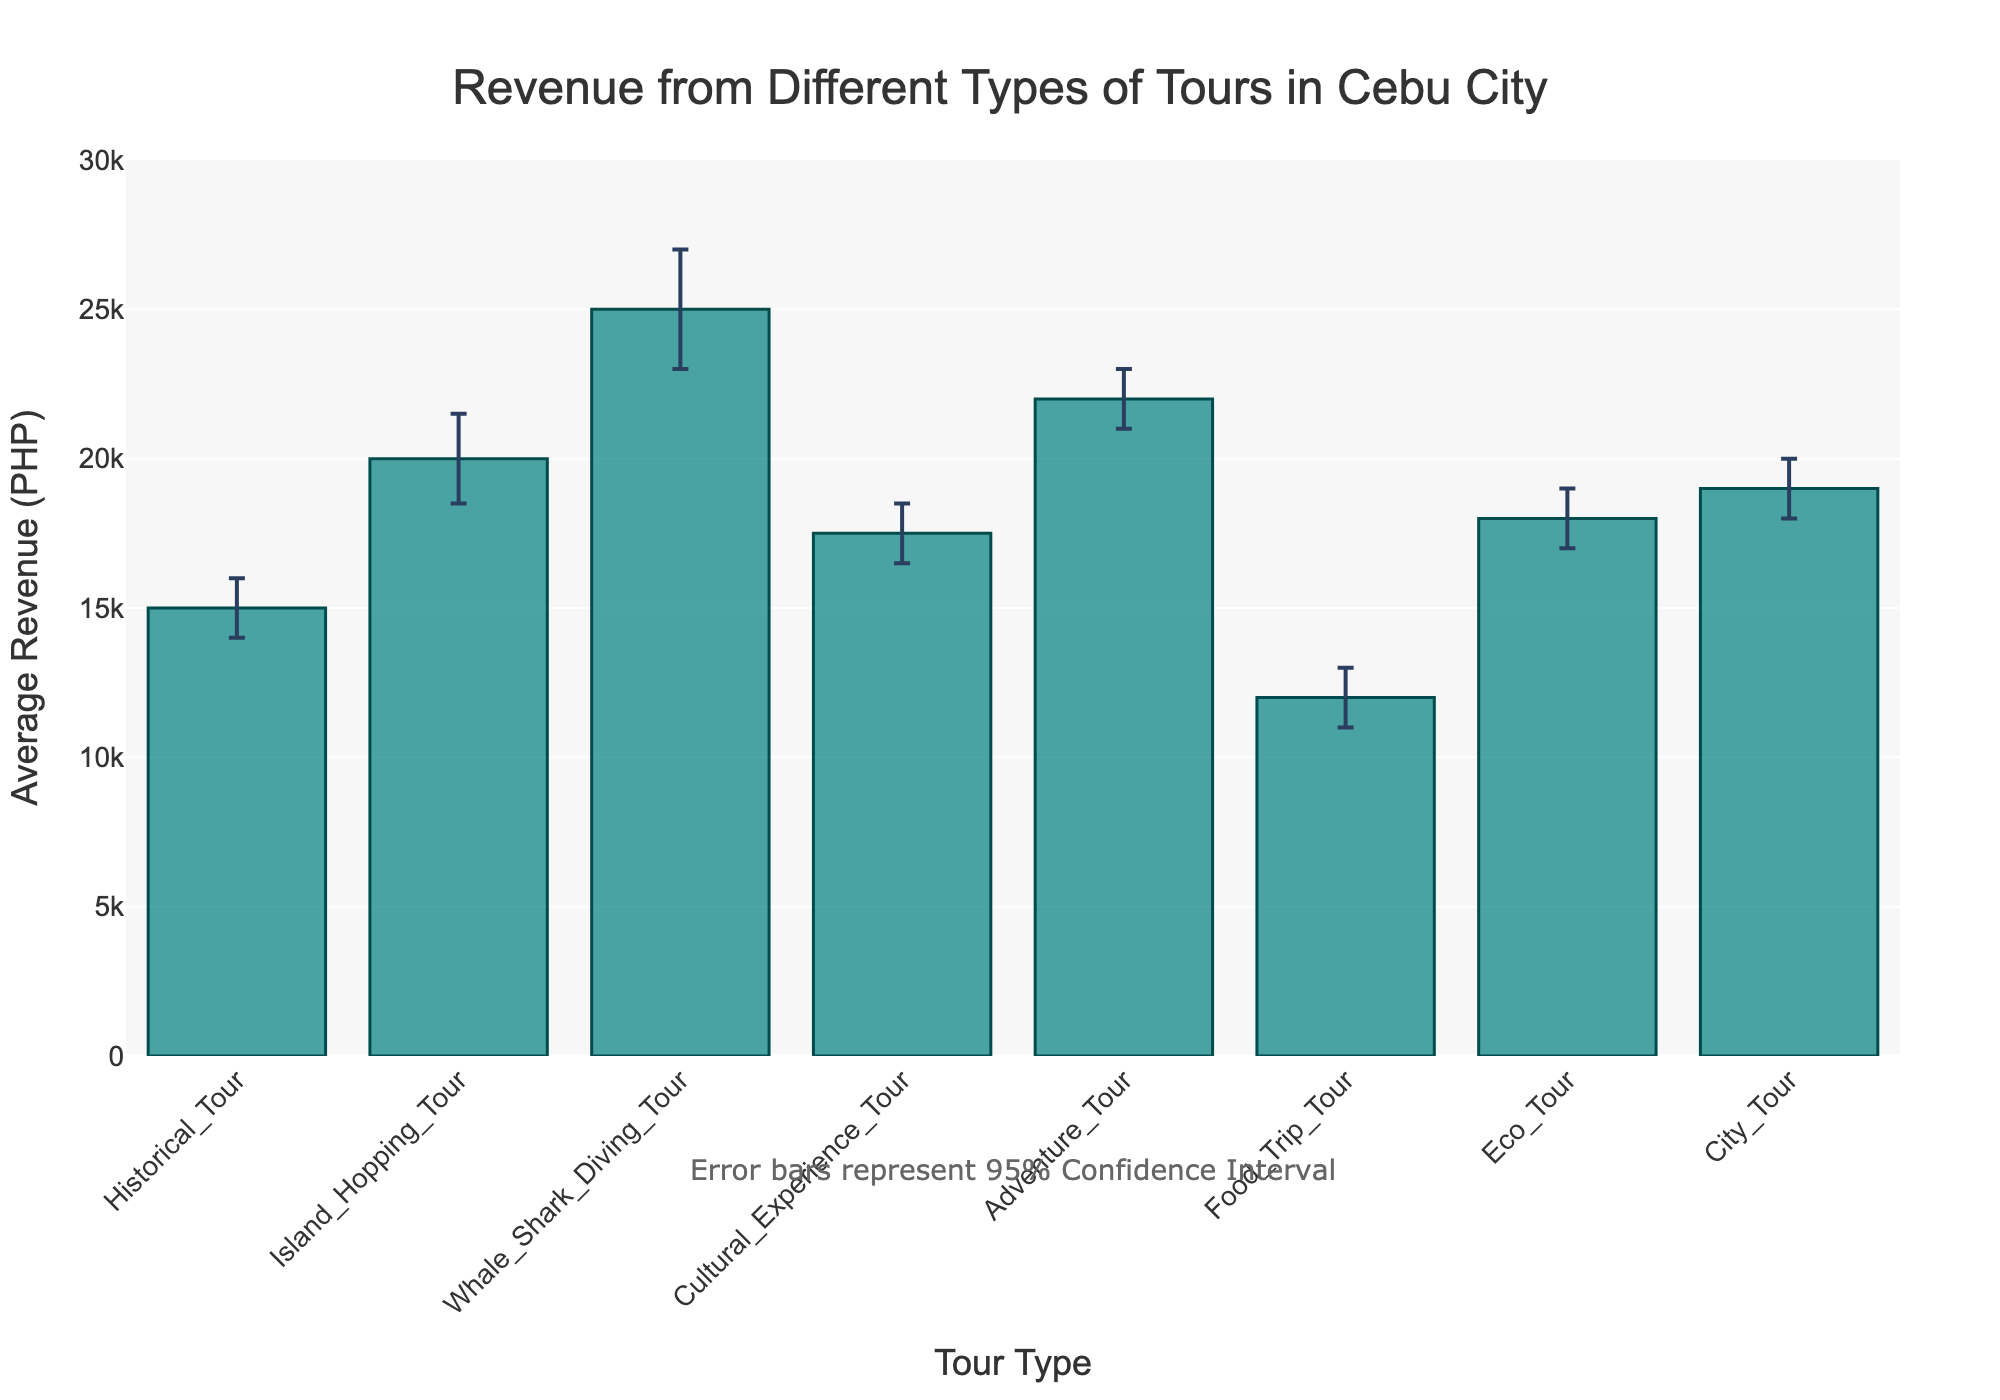What's the title of the figure? The title is located at the top center of the figure and reads "Revenue from Different Types of Tours in Cebu City".
Answer: Revenue from Different Types of Tours in Cebu City How many different types of tours are displayed in the figure? By counting the bars on the x-axis, we can see that there are 8 different types of tours.
Answer: 8 Which type of tour has the highest average revenue? The tallest bar represents the type of tour with the highest average revenue, which is the Whale Shark Diving Tour.
Answer: Whale Shark Diving Tour What is the average revenue for the Cultural Experience Tour? The height of the bar labeled "Cultural Experience Tour" on the x-axis indicates an average revenue of PHP 17,500.
Answer: PHP 17,500 What's the revenue range for the Adventure Tour? The error bars on the Adventure Tour bar show the lower and upper bounds of the confidence interval, which are PHP 21,000 and PHP 23,000 respectively. Thus, the revenue range is from 21,000 to 23,000.
Answer: PHP 21,000 to PHP 23,000 Which tour type has the smallest lower confidence interval? By comparing the lowest points of the error bars, the Food Trip Tour has the smallest lower confidence interval at PHP 11,000.
Answer: Food Trip Tour How much higher is the upper confidence interval of the Whale Shark Diving Tour compared to the upper confidence interval of the Food Trip Tour? The upper confidence interval for the Whale Shark Diving Tour is PHP 27,000, and for the Food Trip Tour, it is PHP 13,000. The difference is 27,000 - 13,000 = 14,000.
Answer: PHP 14,000 What's the difference between the average revenues of the Island Hopping Tour and City Tour? The average revenue of Island Hopping Tour is PHP 20,000 and City Tour is PHP 19,000. The difference is 20,000 - 19,000 = 1,000.
Answer: PHP 1,000 Which tours have overlapping revenue ranges? Tours with overlapping confidence intervals share common values in their ranges. Adventure Tour (21,000 - 23,000) overlaps with Whale Shark Diving Tour (23,000 - 27,000) and also with City Tour (18,000 - 20,000).
Answer: Adventure Tour with Whale Shark Diving Tour and City Tour How much confidence interval overlap (if any) is there between the Historical Tour and Island Hopping Tour? The Historical Tour (14,000 - 16,000) and Island Hopping Tour (18,500 - 21,500) do not overlap as their intervals do not share any common values.
Answer: None 